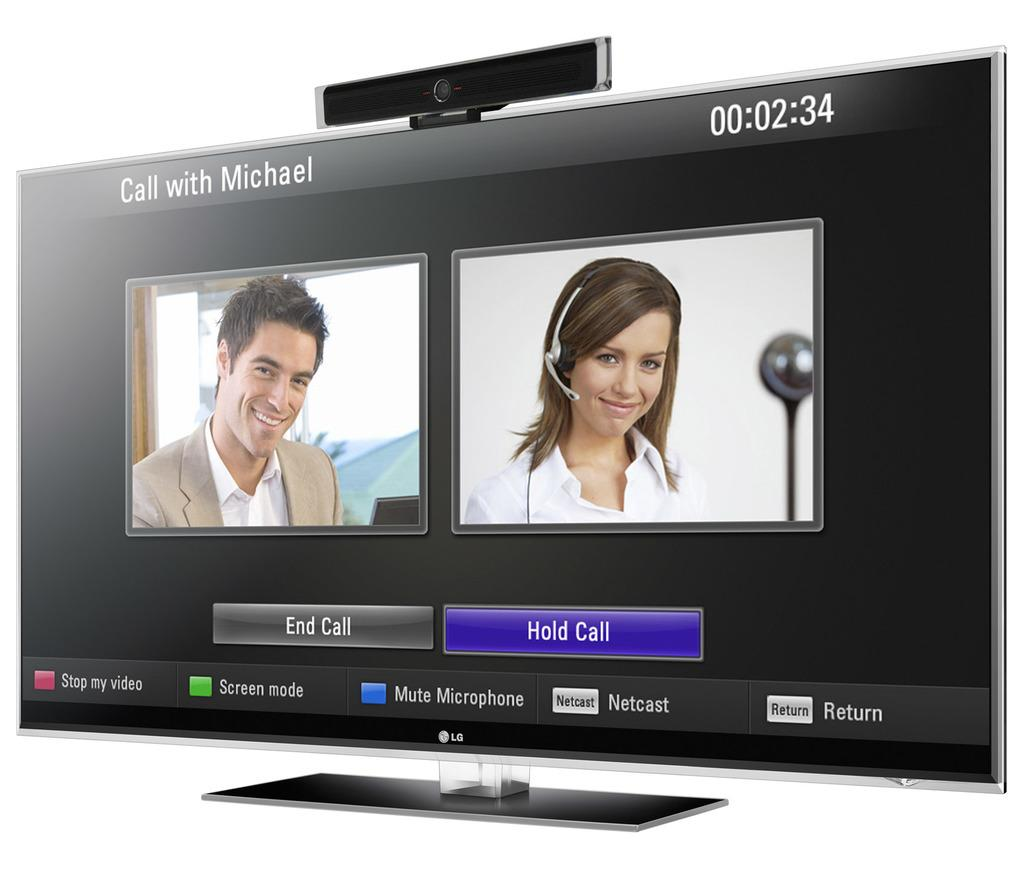What is the main object in the picture? There is a television in the picture. What is being displayed on the television screen? The television is displaying an image of a man and a woman. Are there any additional elements on the television screen? Yes, there are icons visible on the television screen. What is the color of the background in the image? The background of the image is in white color. What type of songs can be heard coming from the man's stomach in the image? There is no man or any indication of a stomach in the image; it only features a television displaying an image of a man and a woman. 